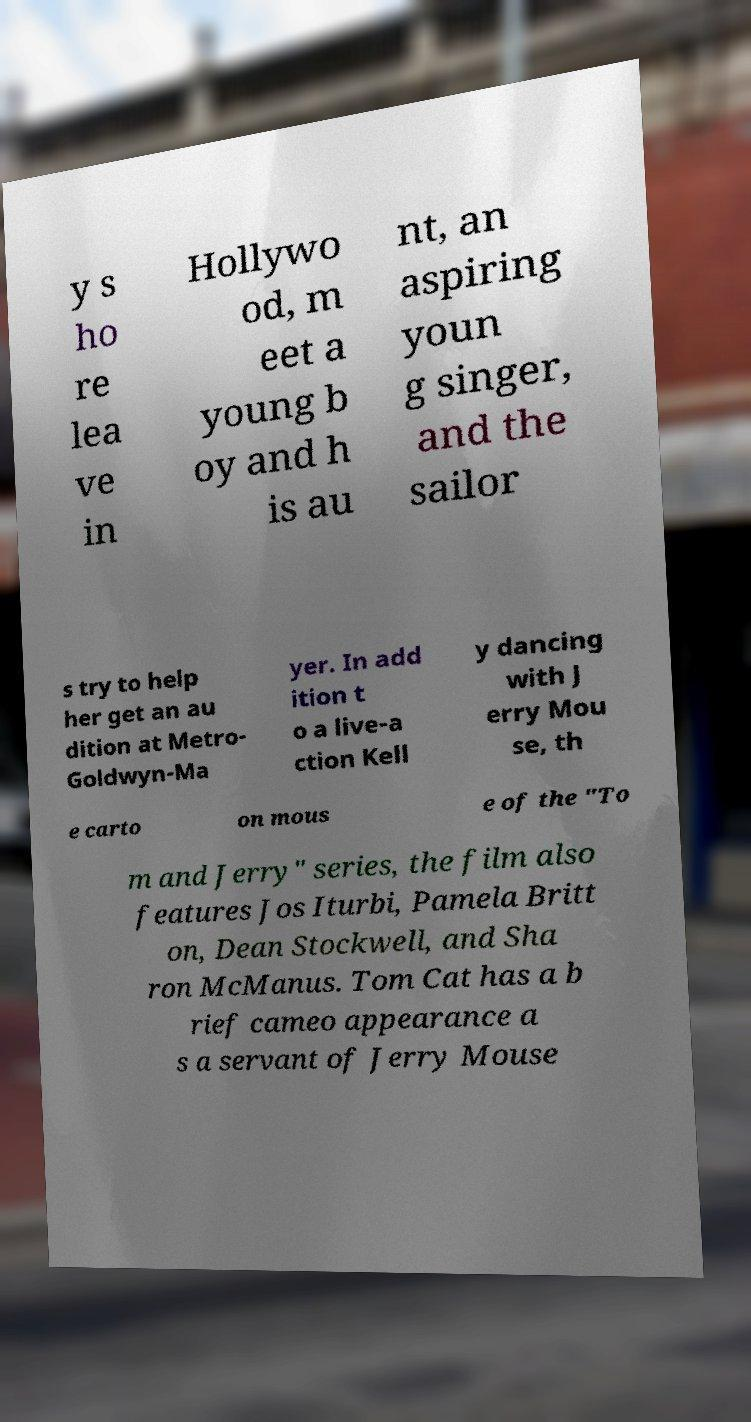Could you extract and type out the text from this image? y s ho re lea ve in Hollywo od, m eet a young b oy and h is au nt, an aspiring youn g singer, and the sailor s try to help her get an au dition at Metro- Goldwyn-Ma yer. In add ition t o a live-a ction Kell y dancing with J erry Mou se, th e carto on mous e of the "To m and Jerry" series, the film also features Jos Iturbi, Pamela Britt on, Dean Stockwell, and Sha ron McManus. Tom Cat has a b rief cameo appearance a s a servant of Jerry Mouse 